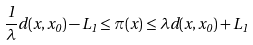<formula> <loc_0><loc_0><loc_500><loc_500>\frac { 1 } { \lambda } d ( x , x _ { 0 } ) - L _ { 1 } \leq \pi ( x ) \leq \lambda d ( x , x _ { 0 } ) + L _ { 1 }</formula> 